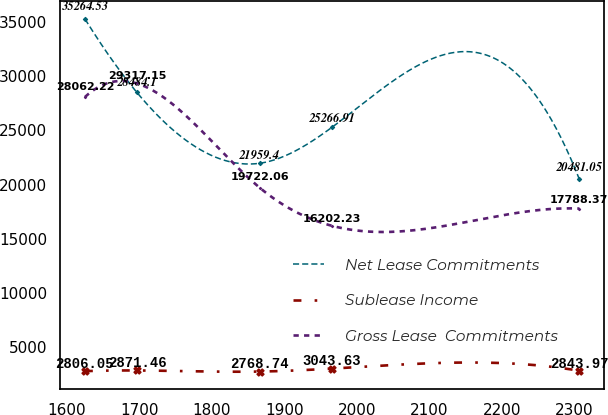<chart> <loc_0><loc_0><loc_500><loc_500><line_chart><ecel><fcel>Net Lease Commitments<fcel>Sublease Income<fcel>Gross Lease  Commitments<nl><fcel>1625.02<fcel>35264.5<fcel>2806.05<fcel>28062.2<nl><fcel>1696.73<fcel>28484.1<fcel>2871.46<fcel>29317.2<nl><fcel>1865.73<fcel>21959.4<fcel>2768.74<fcel>19722.1<nl><fcel>1965.38<fcel>25266.9<fcel>3043.63<fcel>16202.2<nl><fcel>2306.63<fcel>20481<fcel>2843.97<fcel>17788.4<nl></chart> 